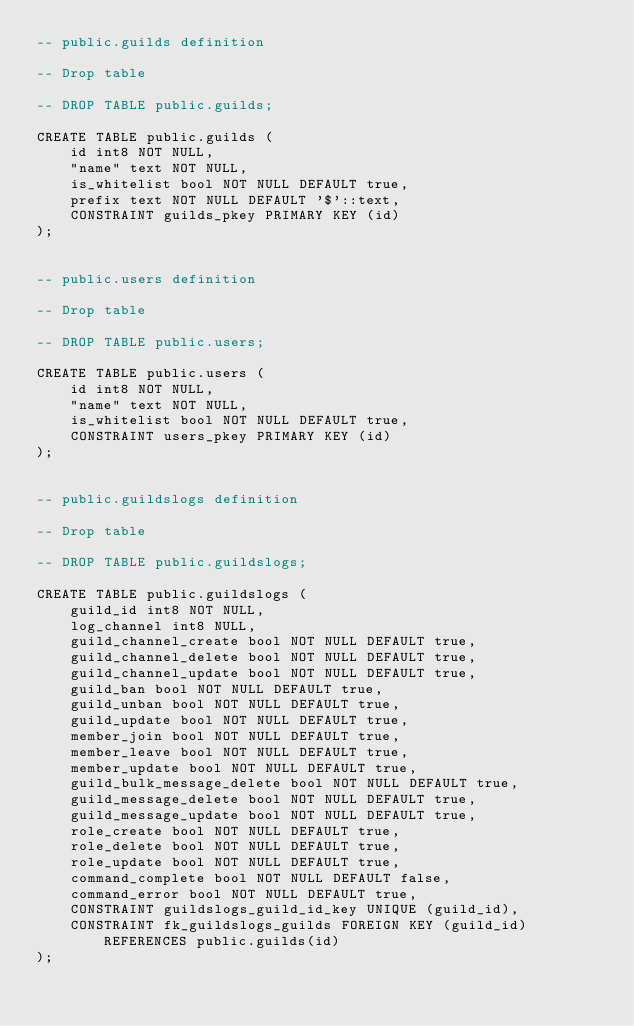<code> <loc_0><loc_0><loc_500><loc_500><_SQL_>-- public.guilds definition

-- Drop table

-- DROP TABLE public.guilds;

CREATE TABLE public.guilds (
	id int8 NOT NULL,
	"name" text NOT NULL,
	is_whitelist bool NOT NULL DEFAULT true,
	prefix text NOT NULL DEFAULT '$'::text,
	CONSTRAINT guilds_pkey PRIMARY KEY (id)
);


-- public.users definition

-- Drop table

-- DROP TABLE public.users;

CREATE TABLE public.users (
	id int8 NOT NULL,
	"name" text NOT NULL,
	is_whitelist bool NOT NULL DEFAULT true,
	CONSTRAINT users_pkey PRIMARY KEY (id)
);


-- public.guildslogs definition

-- Drop table

-- DROP TABLE public.guildslogs;

CREATE TABLE public.guildslogs (
	guild_id int8 NOT NULL,
	log_channel int8 NULL,
	guild_channel_create bool NOT NULL DEFAULT true,
	guild_channel_delete bool NOT NULL DEFAULT true,
	guild_channel_update bool NOT NULL DEFAULT true,
	guild_ban bool NOT NULL DEFAULT true,
	guild_unban bool NOT NULL DEFAULT true,
	guild_update bool NOT NULL DEFAULT true,
	member_join bool NOT NULL DEFAULT true,
	member_leave bool NOT NULL DEFAULT true,
	member_update bool NOT NULL DEFAULT true,
	guild_bulk_message_delete bool NOT NULL DEFAULT true,
	guild_message_delete bool NOT NULL DEFAULT true,
	guild_message_update bool NOT NULL DEFAULT true,
	role_create bool NOT NULL DEFAULT true,
	role_delete bool NOT NULL DEFAULT true,
	role_update bool NOT NULL DEFAULT true,
	command_complete bool NOT NULL DEFAULT false,
	command_error bool NOT NULL DEFAULT true,
	CONSTRAINT guildslogs_guild_id_key UNIQUE (guild_id),
	CONSTRAINT fk_guildslogs_guilds FOREIGN KEY (guild_id) REFERENCES public.guilds(id)
); 
</code> 